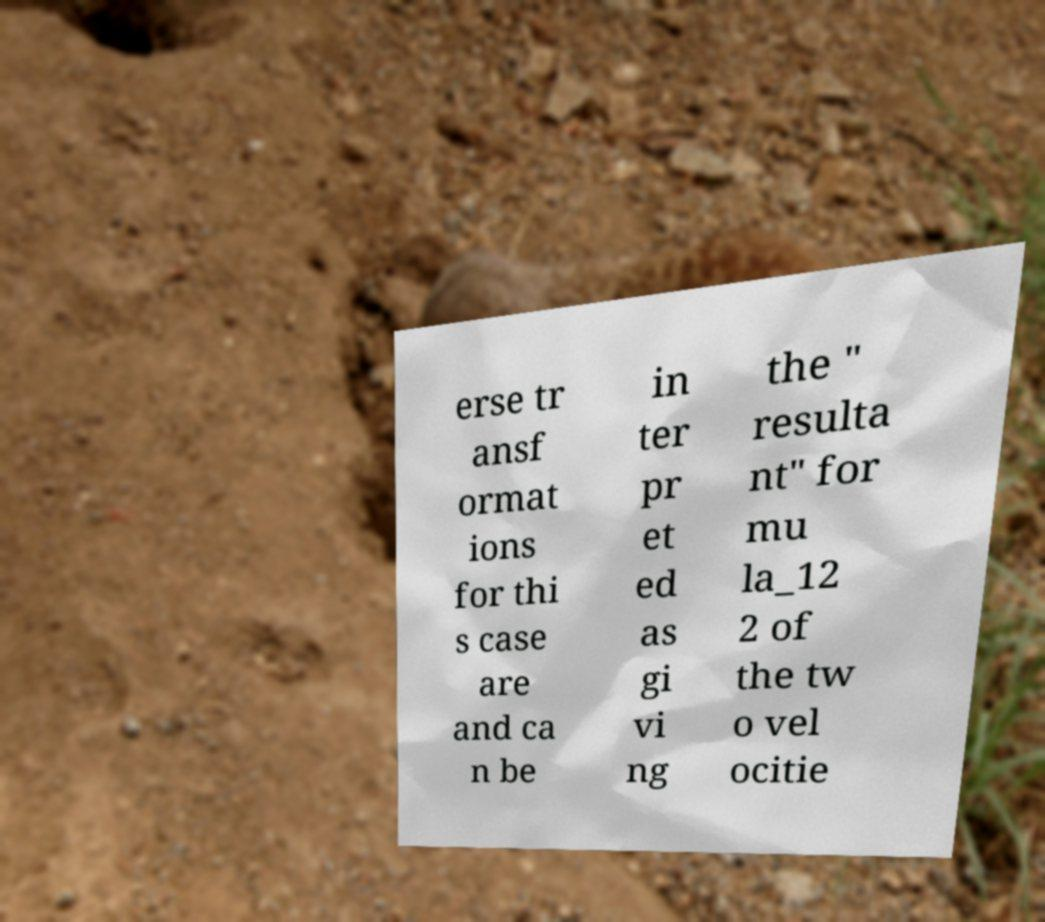Can you read and provide the text displayed in the image?This photo seems to have some interesting text. Can you extract and type it out for me? erse tr ansf ormat ions for thi s case are and ca n be in ter pr et ed as gi vi ng the " resulta nt" for mu la_12 2 of the tw o vel ocitie 